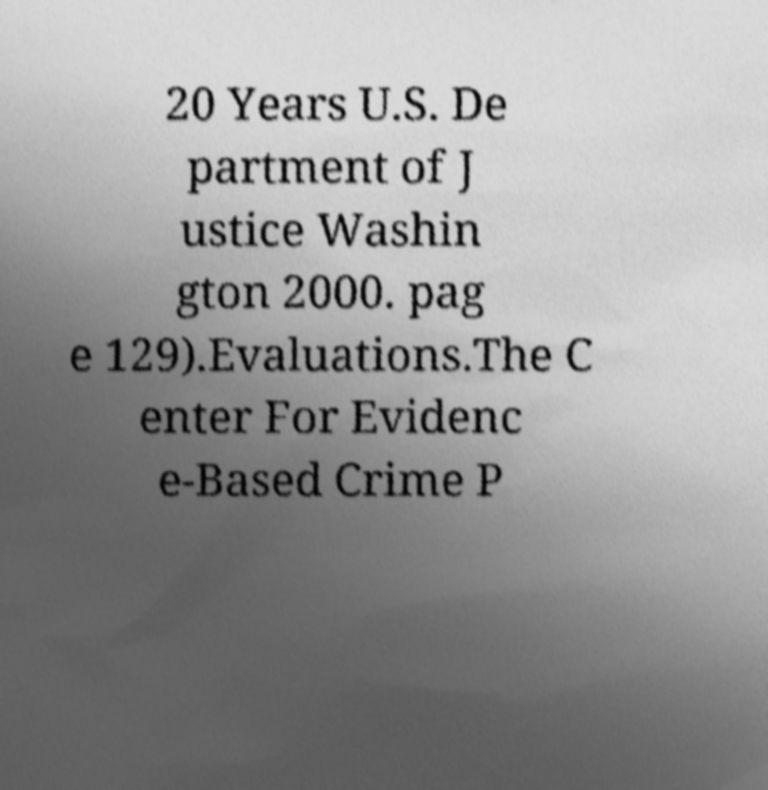Could you assist in decoding the text presented in this image and type it out clearly? 20 Years U.S. De partment of J ustice Washin gton 2000. pag e 129).Evaluations.The C enter For Evidenc e-Based Crime P 